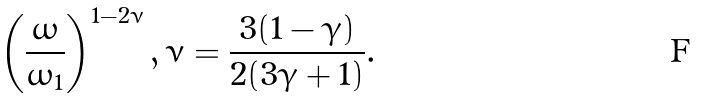Convert formula to latex. <formula><loc_0><loc_0><loc_500><loc_500>\left ( \frac { \omega } { \omega _ { 1 } } \right ) ^ { 1 - 2 \nu } , \nu = \frac { 3 ( 1 - \gamma ) } { 2 ( 3 \gamma + 1 ) } .</formula> 